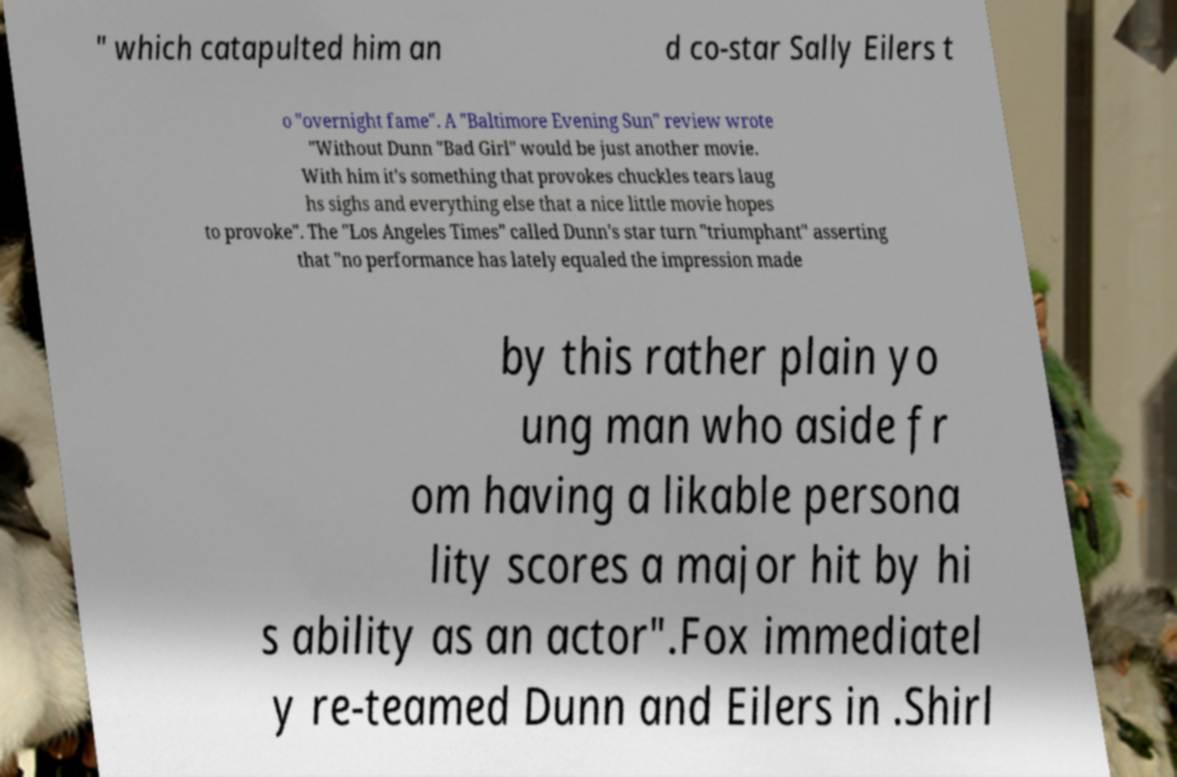There's text embedded in this image that I need extracted. Can you transcribe it verbatim? " which catapulted him an d co-star Sally Eilers t o "overnight fame". A "Baltimore Evening Sun" review wrote "Without Dunn "Bad Girl" would be just another movie. With him it's something that provokes chuckles tears laug hs sighs and everything else that a nice little movie hopes to provoke". The "Los Angeles Times" called Dunn's star turn "triumphant" asserting that "no performance has lately equaled the impression made by this rather plain yo ung man who aside fr om having a likable persona lity scores a major hit by hi s ability as an actor".Fox immediatel y re-teamed Dunn and Eilers in .Shirl 